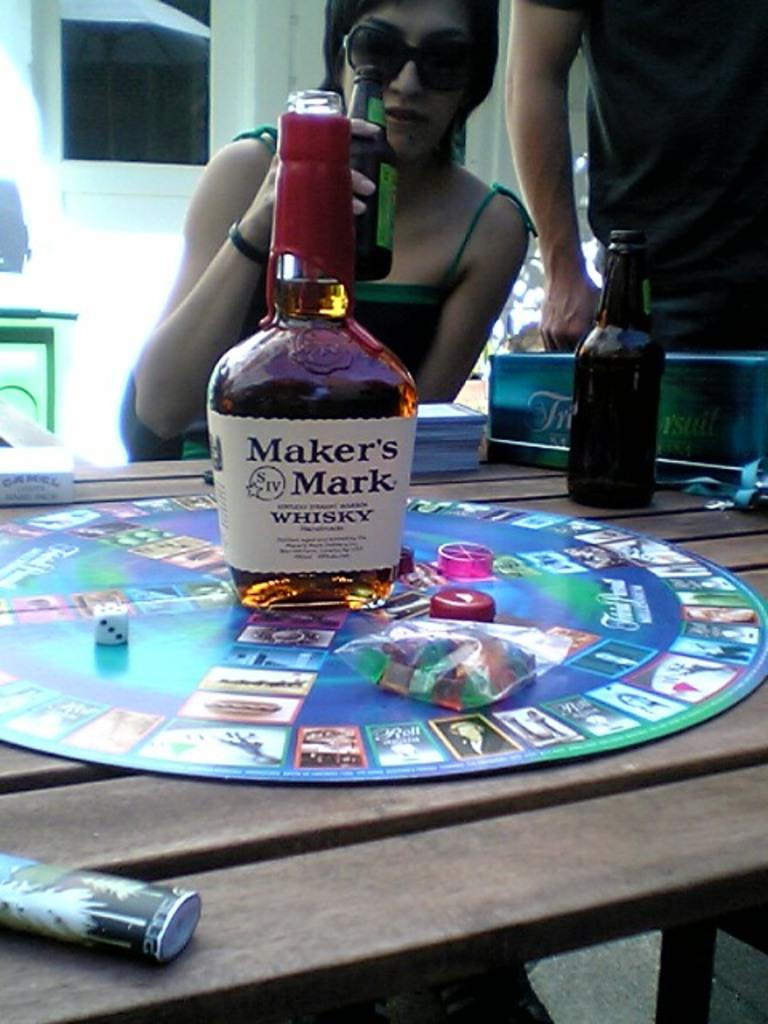What is on the table in the image? There is a whisky bottle on a table. Can you describe the person in the image? There is a woman behind the table. How many pizzas are on the table in the image? There are no pizzas present in the image; only a whisky bottle is visible on the table. 